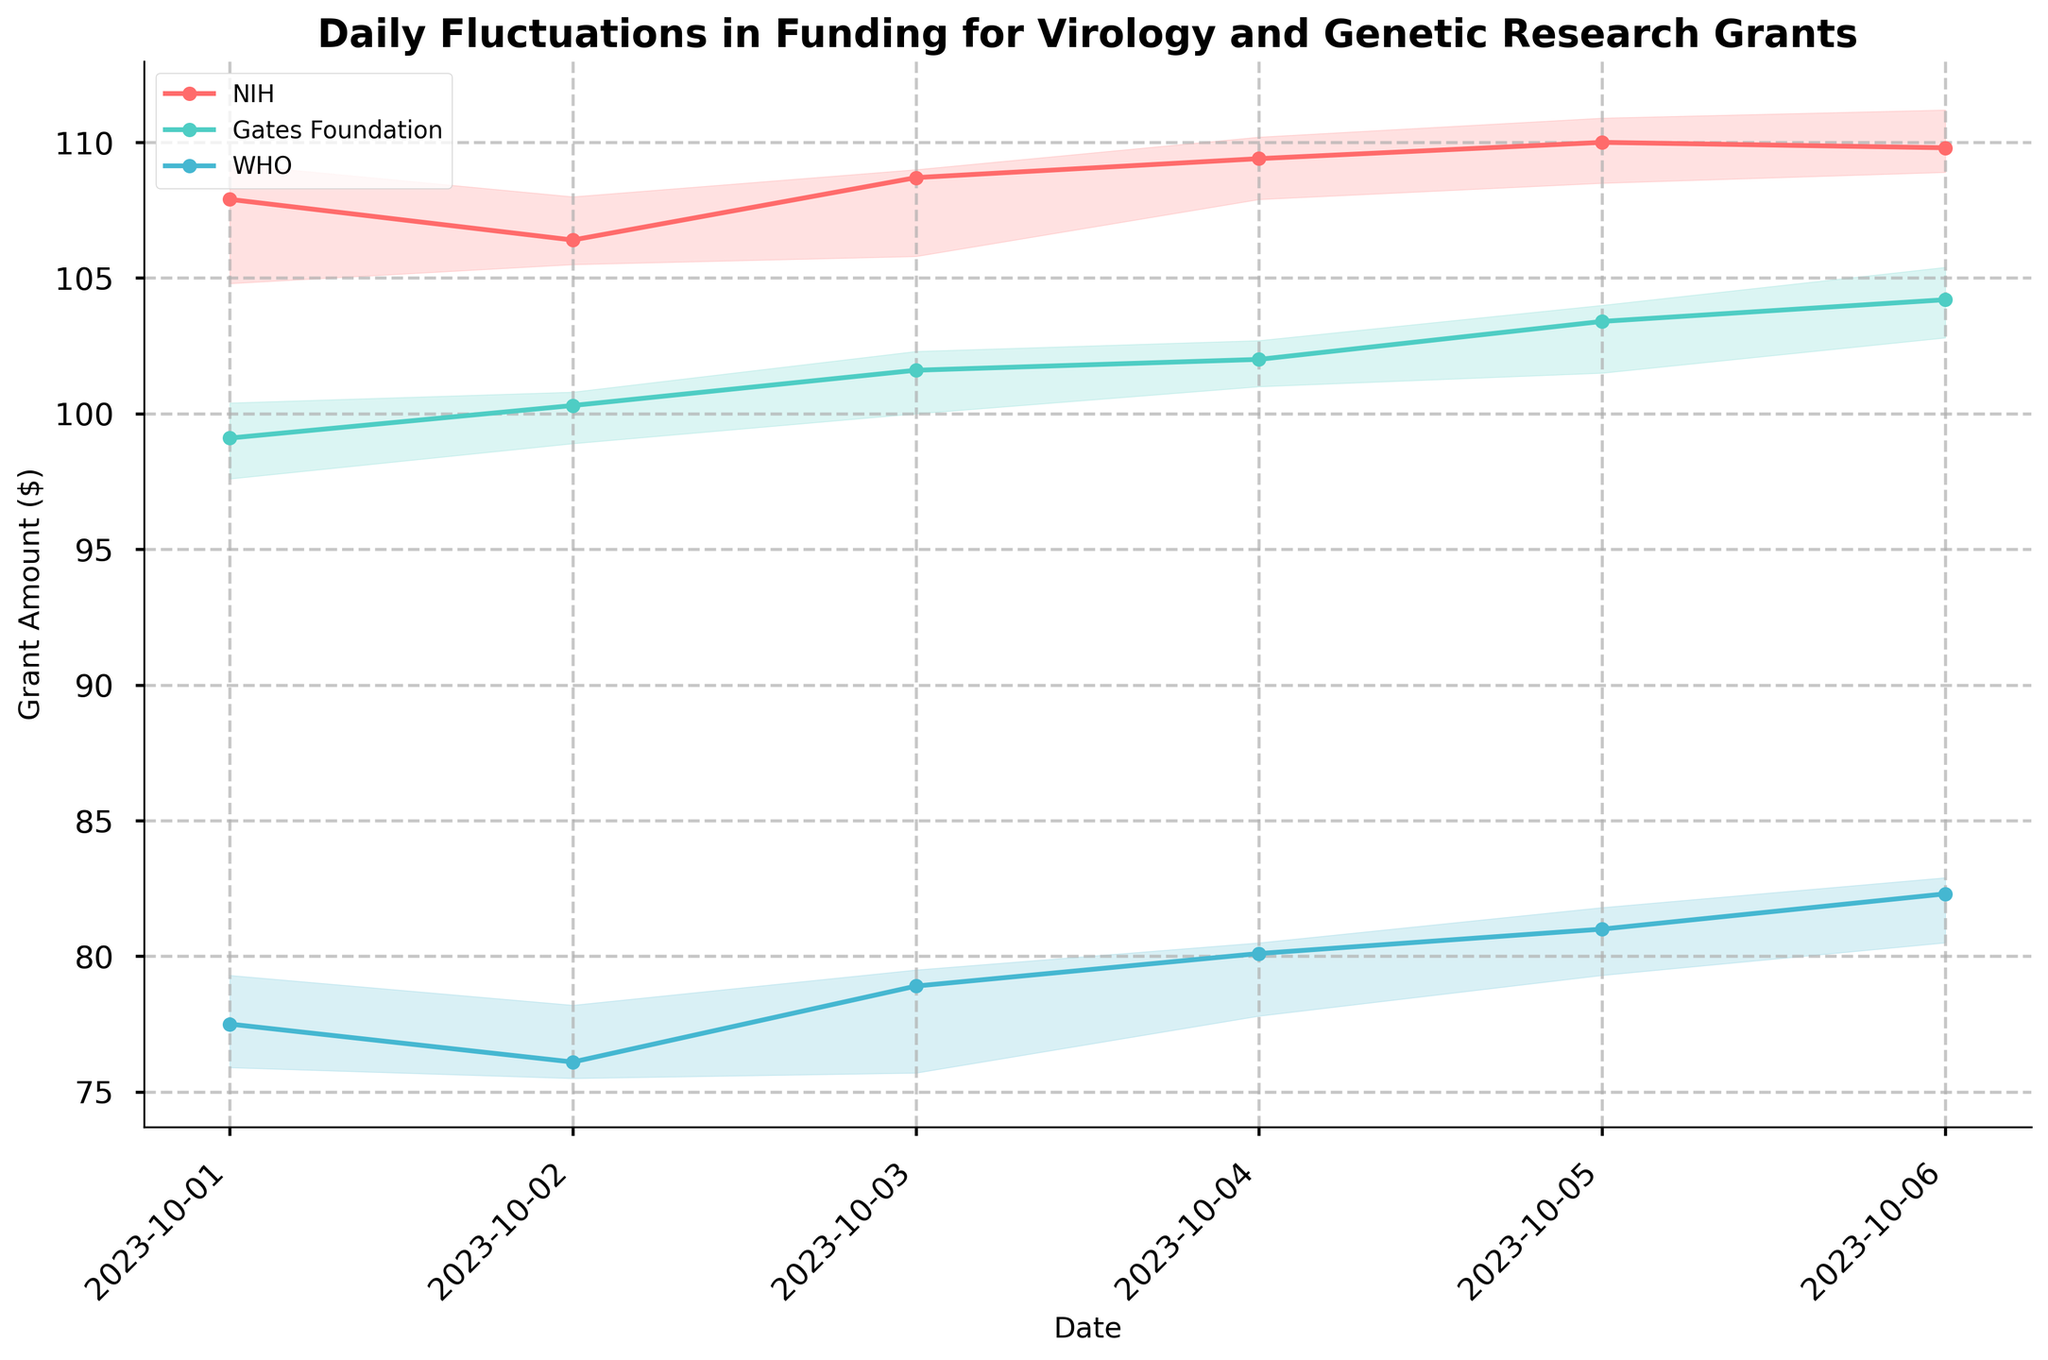What is the title of the plot? The title is displayed at the top of the plot in bold and larger font.
Answer: Daily Fluctuations in Funding for Virology and Genetic Research Grants How many data points are plotted for the NIH funding? Count the number of markers along the NIH line.
Answer: 6 How does the closing price of WHO grants change from October 1 to October 6? Check the closing price of WHO on October 1 and compare it to October 6.
Answer: Increased from 77.5 to 82.3 Which funder had the highest closing price on October 4th? Look at the closing prices for all three funders on October 4th and identify the highest.
Answer: NIH What was the lowest high price recorded by the Gates Foundation between October 1 and October 6? Examine the 'High' prices for the Gates Foundation and identify the lowest one.
Answer: 100.4 Which funder had the most significant increase in closing price between October 1 and October 6? Calculate the difference in closing prices over the period for each funder and compare.
Answer: WHO What is the average closing price of NIH over the plotted period? Sum the closing prices for NIH over the period and divide by the number of days.
Answer: (107.9 + 106.4 + 108.7 + 109.4 + 110.0 + 109.8) / 6 = 108.7 On which date does the Gates Foundation have the highest volume of funding? Compare the volume values for the Gates Foundation across all dates.
Answer: October 6 What trend can you observe in the closing prices of the NIH funding from October 1 to October 6? Observe the closing prices of NIH funding over the days to identify any trend.
Answer: Generally increasing 